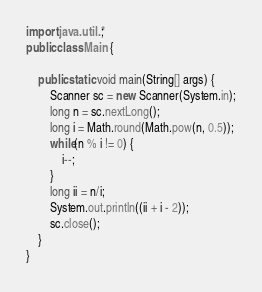Convert code to text. <code><loc_0><loc_0><loc_500><loc_500><_Java_>import java.util.*;
public class Main {

	public static void main(String[] args) {
		Scanner sc = new Scanner(System.in);
		long n = sc.nextLong();
		long i = Math.round(Math.pow(n, 0.5));
		while(n % i != 0) {
			i--;			
		}
		long ii = n/i;
		System.out.println((ii + i - 2));
		sc.close();
	}
}
</code> 